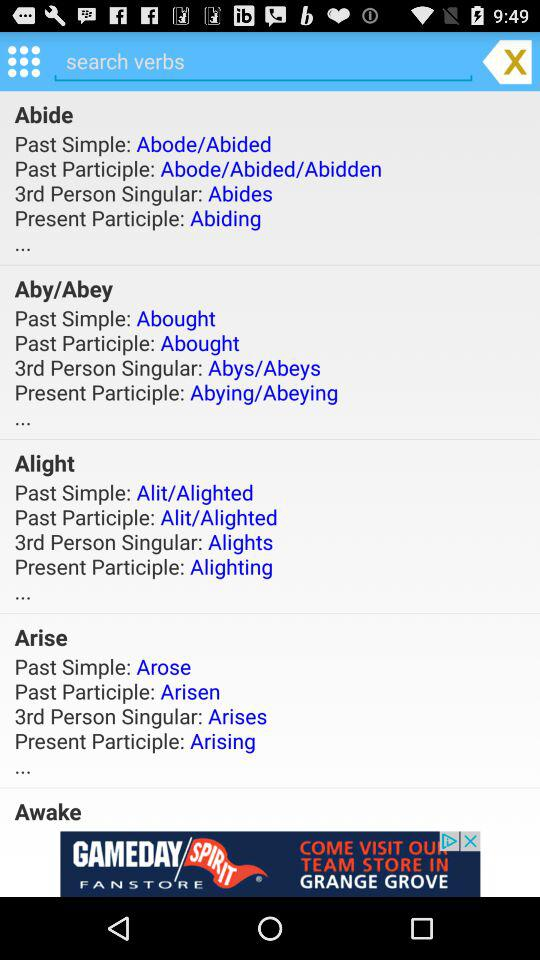What is the present participle of "Abide"? The present participle is "Abiding". 